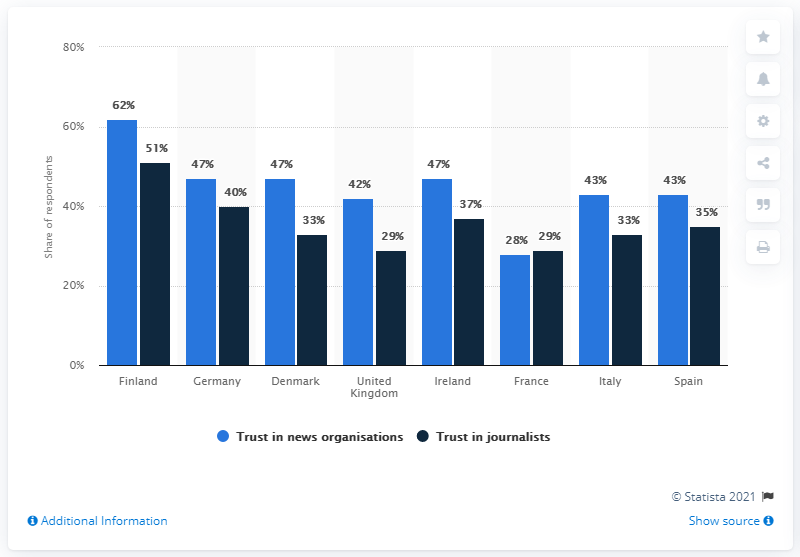Specify some key components in this picture. According to data from Finland, 51% of respondents reported having trust in journalists. I would like to use data from France, Italy, and Spain to find the average of all the data. According to the data, Finland had the highest level of trust in news organizations among all the countries surveyed. 